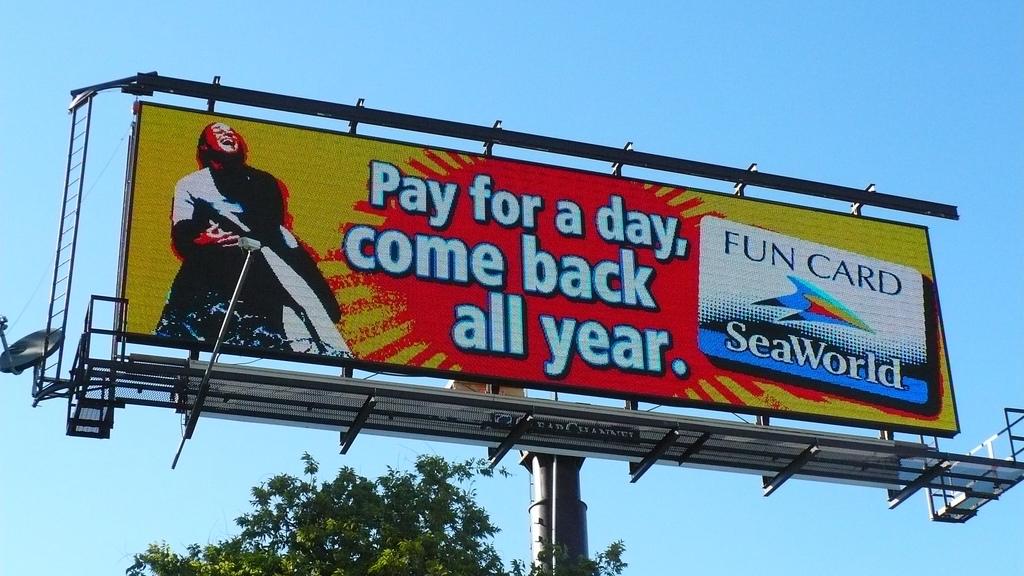What amusement park is being advertised?
Your answer should be very brief. Seaworld. What kind of card can you get?
Give a very brief answer. Fun card. 